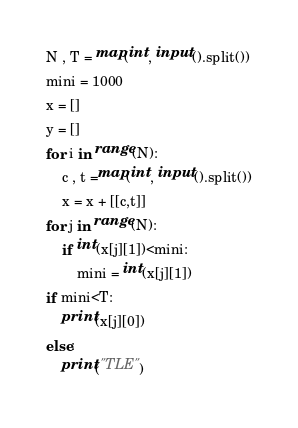<code> <loc_0><loc_0><loc_500><loc_500><_Python_>N , T = map(int, input().split())
mini = 1000
x = []
y = []
for i in range(N):
    c , t =map(int, input().split())
    x = x + [[c,t]]
for j in range(N):
    if int(x[j][1])<mini:
        mini = int(x[j][1])
if mini<T:
    print(x[j][0])
else:
    print("TLE")</code> 